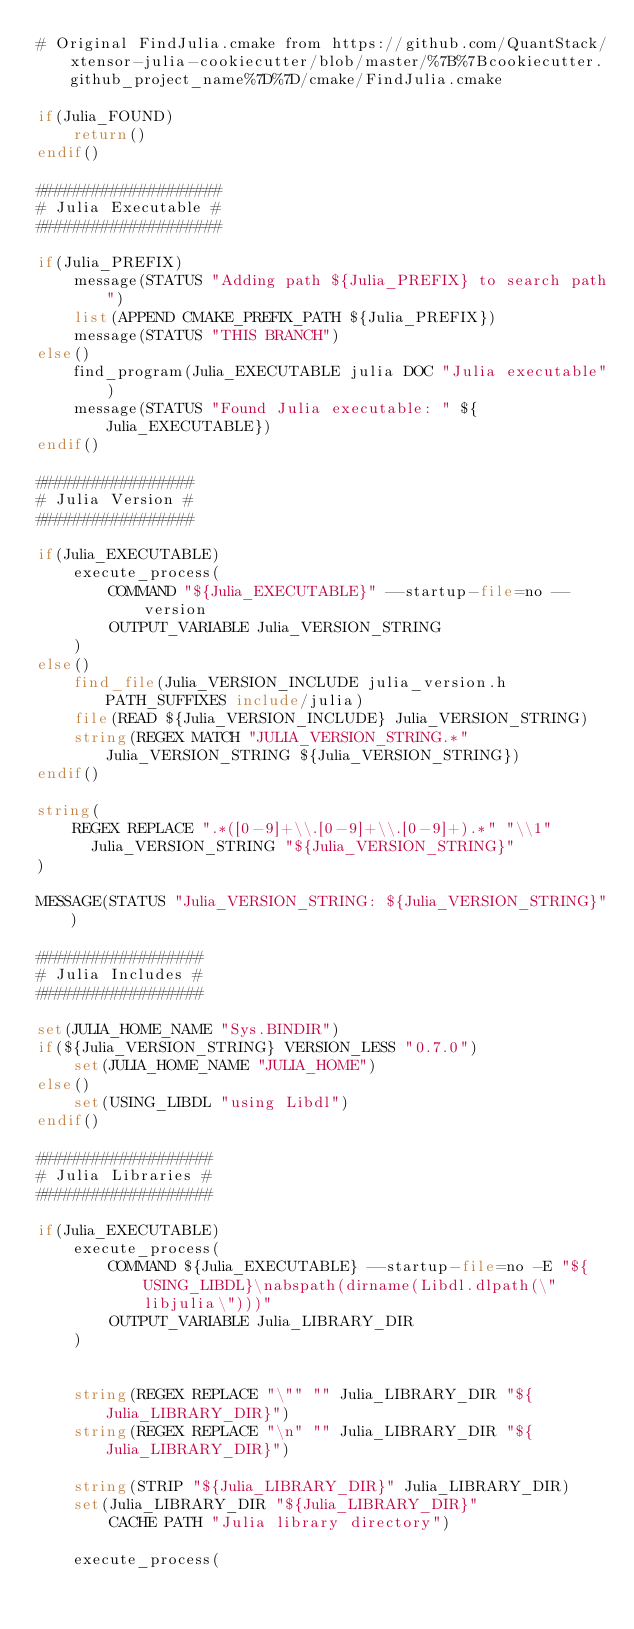<code> <loc_0><loc_0><loc_500><loc_500><_CMake_># Original FindJulia.cmake from https://github.com/QuantStack/xtensor-julia-cookiecutter/blob/master/%7B%7Bcookiecutter.github_project_name%7D%7D/cmake/FindJulia.cmake

if(Julia_FOUND)
    return()
endif()

####################
# Julia Executable #
####################

if(Julia_PREFIX)
    message(STATUS "Adding path ${Julia_PREFIX} to search path")
    list(APPEND CMAKE_PREFIX_PATH ${Julia_PREFIX})
    message(STATUS "THIS BRANCH")
else()
    find_program(Julia_EXECUTABLE julia DOC "Julia executable")
    message(STATUS "Found Julia executable: " ${Julia_EXECUTABLE})
endif()

#################
# Julia Version #
#################

if(Julia_EXECUTABLE)
    execute_process(
        COMMAND "${Julia_EXECUTABLE}" --startup-file=no --version
        OUTPUT_VARIABLE Julia_VERSION_STRING
    )
else()
    find_file(Julia_VERSION_INCLUDE julia_version.h PATH_SUFFIXES include/julia)
    file(READ ${Julia_VERSION_INCLUDE} Julia_VERSION_STRING)
    string(REGEX MATCH "JULIA_VERSION_STRING.*" Julia_VERSION_STRING ${Julia_VERSION_STRING})
endif()

string(
    REGEX REPLACE ".*([0-9]+\\.[0-9]+\\.[0-9]+).*" "\\1"
      Julia_VERSION_STRING "${Julia_VERSION_STRING}"
)

MESSAGE(STATUS "Julia_VERSION_STRING: ${Julia_VERSION_STRING}")

##################
# Julia Includes #
##################

set(JULIA_HOME_NAME "Sys.BINDIR")
if(${Julia_VERSION_STRING} VERSION_LESS "0.7.0")
    set(JULIA_HOME_NAME "JULIA_HOME")
else()
    set(USING_LIBDL "using Libdl")
endif()

###################
# Julia Libraries #
###################

if(Julia_EXECUTABLE)
    execute_process(
        COMMAND ${Julia_EXECUTABLE} --startup-file=no -E "${USING_LIBDL}\nabspath(dirname(Libdl.dlpath(\"libjulia\")))"
        OUTPUT_VARIABLE Julia_LIBRARY_DIR
    )


    string(REGEX REPLACE "\"" "" Julia_LIBRARY_DIR "${Julia_LIBRARY_DIR}")
    string(REGEX REPLACE "\n" "" Julia_LIBRARY_DIR "${Julia_LIBRARY_DIR}")

    string(STRIP "${Julia_LIBRARY_DIR}" Julia_LIBRARY_DIR)
    set(Julia_LIBRARY_DIR "${Julia_LIBRARY_DIR}"
        CACHE PATH "Julia library directory")

    execute_process(</code> 